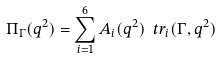Convert formula to latex. <formula><loc_0><loc_0><loc_500><loc_500>\Pi _ { \Gamma } ( q ^ { 2 } ) = \sum _ { i = 1 } ^ { 6 } A _ { i } ( q ^ { 2 } ) \ t r _ { i } ( \Gamma , q ^ { 2 } )</formula> 